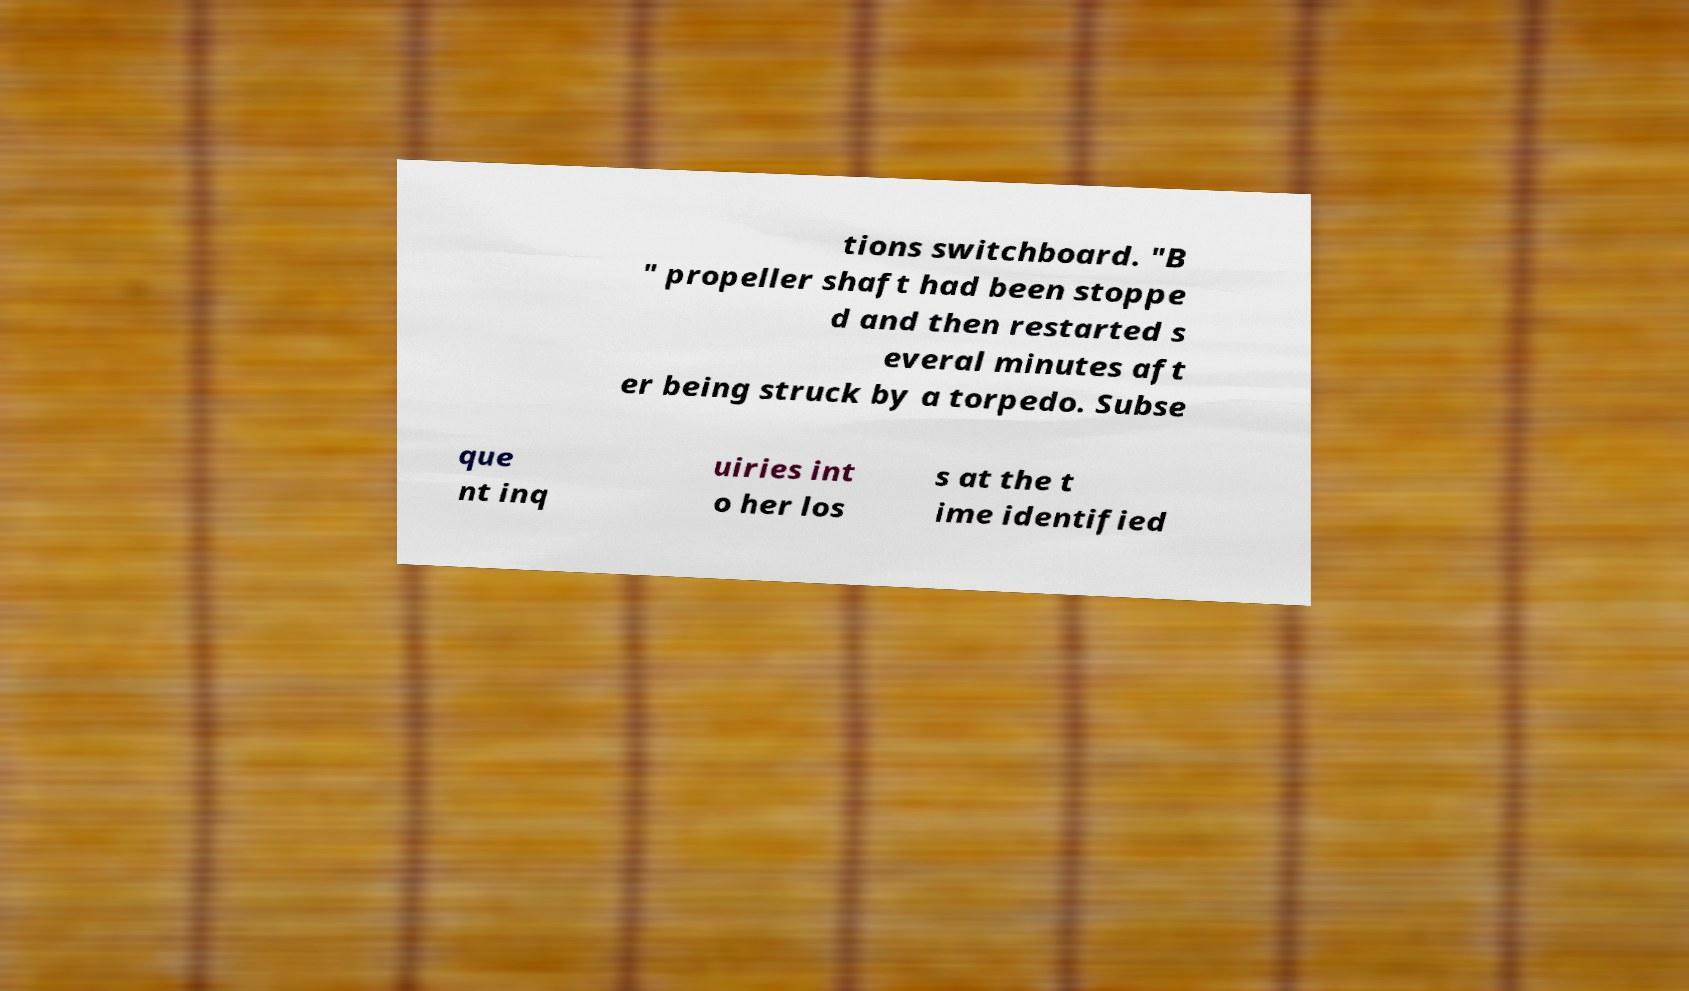Can you read and provide the text displayed in the image?This photo seems to have some interesting text. Can you extract and type it out for me? tions switchboard. "B " propeller shaft had been stoppe d and then restarted s everal minutes aft er being struck by a torpedo. Subse que nt inq uiries int o her los s at the t ime identified 